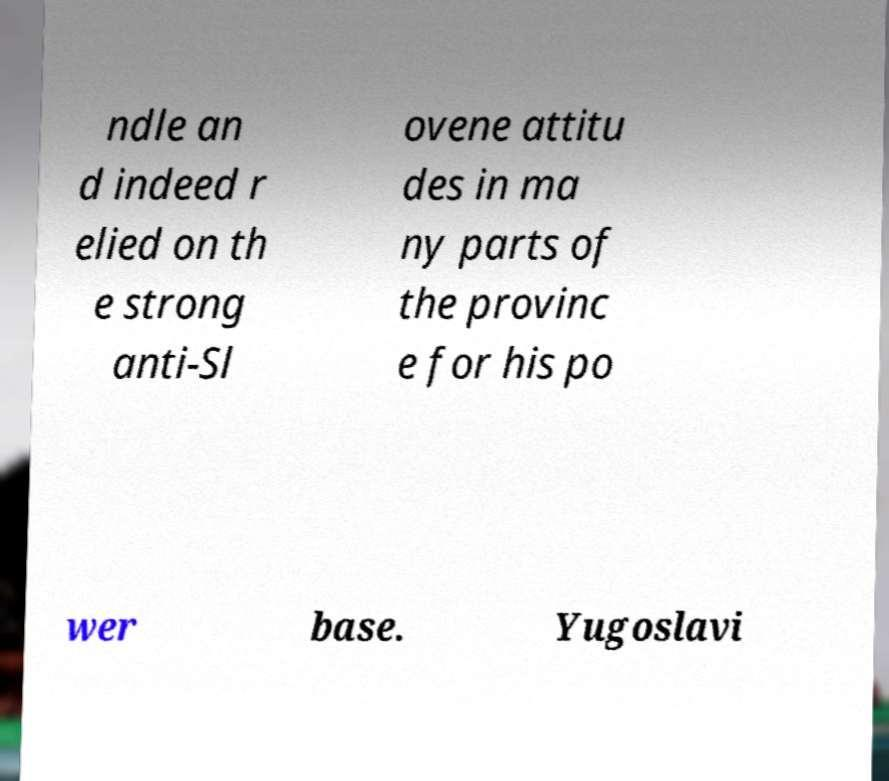For documentation purposes, I need the text within this image transcribed. Could you provide that? ndle an d indeed r elied on th e strong anti-Sl ovene attitu des in ma ny parts of the provinc e for his po wer base. Yugoslavi 